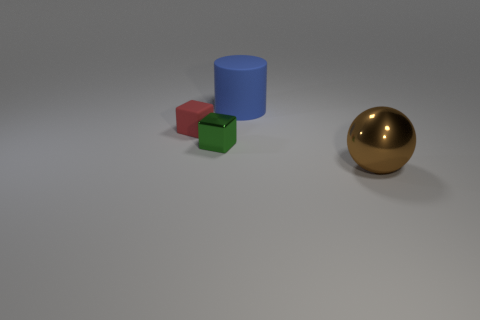Add 3 big spheres. How many objects exist? 7 Subtract all red blocks. How many blocks are left? 1 Subtract all cylinders. How many objects are left? 3 Add 1 small red matte blocks. How many small red matte blocks are left? 2 Add 3 big brown things. How many big brown things exist? 4 Subtract 0 gray cylinders. How many objects are left? 4 Subtract 1 cubes. How many cubes are left? 1 Subtract all yellow balls. Subtract all gray cylinders. How many balls are left? 1 Subtract all tiny green rubber spheres. Subtract all tiny metal things. How many objects are left? 3 